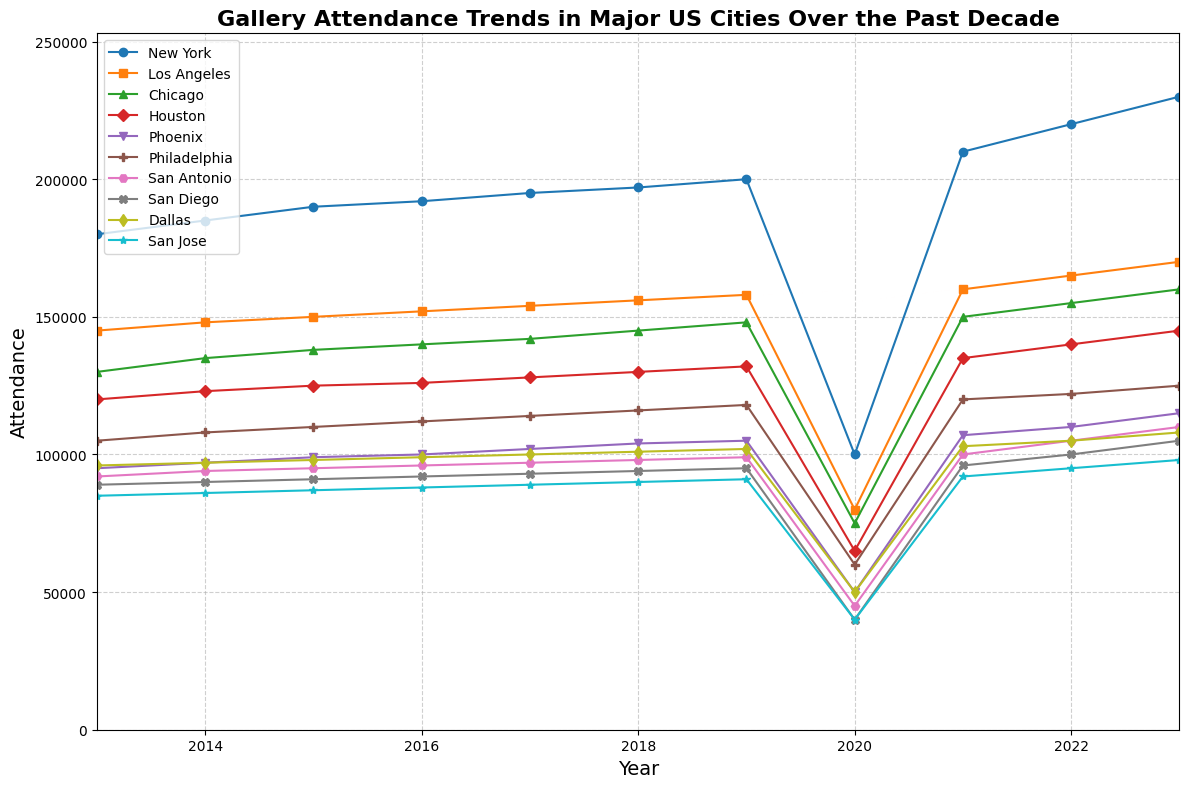What trend can you observe in Phoenix's gallery attendance from 2013 to 2023? Phoenix's attendance shows a general increasing trend from 95,000 in 2013 to 115,000 in 2023, except for a significant drop in 2020.
Answer: Increasing, with a dip in 2020 Which city had the highest gallery attendance in 2020? By observing the lines and markers on the plot for 2020, New York had the highest attendance, noted with the highest point in that year.
Answer: New York How does Philadelphia's gallery attendance in 2023 compare to its attendance in 2013? Philadelphia's attendance increased from 105,000 in 2013 to 125,000 in 2023.
Answer: Increased What is the approximate average gallery attendance of Los Angeles over the decade? Sum the attendance values for Los Angeles from 2013 to 2023 (145,000 + 148,000 + 150,000 + 152,000 + 154,000 + 156,000 + 158,000 + 80,000 + 160,000 + 165,000 + 170,000) and divide by the number of years (11). That is (1,638,000 / 11).
Answer: Approximately 148,909 How did the attendance trends in San Jose and Dallas compare over the decade? Both cities show an overall increasing trend but had a significant drop in 2020. San Jose started lower than Dallas but surpassed it slightly in the later years.
Answer: Both increased, with San Jose surpassing Dallas later Which city experienced the most significant drop in gallery attendance in 2020, and by how much? Calculate the difference in attendance from 2019 to 2020 for each city and identify the largest drop. New York dropped from 200,000 to 100,000; the most significant drop is 100,000.
Answer: New York, by 100,000 What's the difference in gallery attendance between Chicago and Houston in 2023? The attendance for Chicago in 2023 is 160,000, and for Houston, it is 145,000. Subtract Houston's value from Chicago's.
Answer: 15,000 In which year did New York surpass 190,000 in gallery attendance? Look at New York’s trend line and find the year when the value first exceeds 190,000.
Answer: 2016 Compare the attendance growth from 2013 to 2023 for San Antonio and San Diego. Calculate the difference for both cities: San Antonio grew from 92,000 to 110,000, a difference of 18,000; San Diego grew from 89,000 to 105,000, a difference of 16,000.
Answer: San Antonio: 18,000; San Diego: 16,000 What is the range of annual attendances for Philadelphia over the period shown? The minimum attendance for Philadelphia is 60,000 in 2020, and the maximum is 125,000 in 2023. Subtract the minimum from the maximum.
Answer: 65,000 